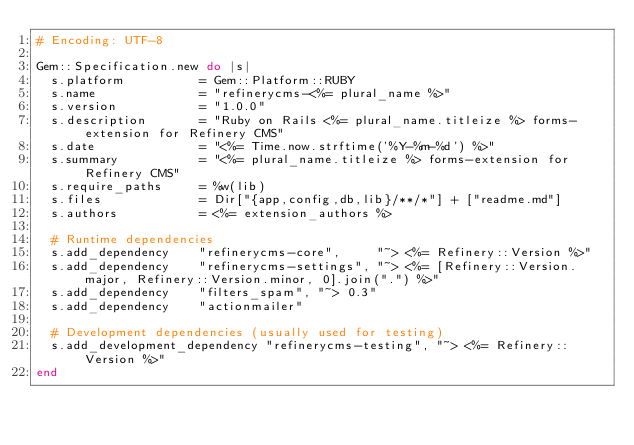<code> <loc_0><loc_0><loc_500><loc_500><_Ruby_># Encoding: UTF-8

Gem::Specification.new do |s|
  s.platform          = Gem::Platform::RUBY
  s.name              = "refinerycms-<%= plural_name %>"
  s.version           = "1.0.0"
  s.description       = "Ruby on Rails <%= plural_name.titleize %> forms-extension for Refinery CMS"
  s.date              = "<%= Time.now.strftime('%Y-%m-%d') %>"
  s.summary           = "<%= plural_name.titleize %> forms-extension for Refinery CMS"
  s.require_paths     = %w(lib)
  s.files             = Dir["{app,config,db,lib}/**/*"] + ["readme.md"]
  s.authors           = <%= extension_authors %>

  # Runtime dependencies
  s.add_dependency    "refinerycms-core",     "~> <%= Refinery::Version %>"
  s.add_dependency    "refinerycms-settings", "~> <%= [Refinery::Version.major, Refinery::Version.minor, 0].join(".") %>"
  s.add_dependency    "filters_spam", "~> 0.3"
  s.add_dependency    "actionmailer"

  # Development dependencies (usually used for testing)
  s.add_development_dependency "refinerycms-testing", "~> <%= Refinery::Version %>"
end
</code> 